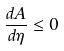Convert formula to latex. <formula><loc_0><loc_0><loc_500><loc_500>\frac { d A } { d \eta } \leq 0</formula> 